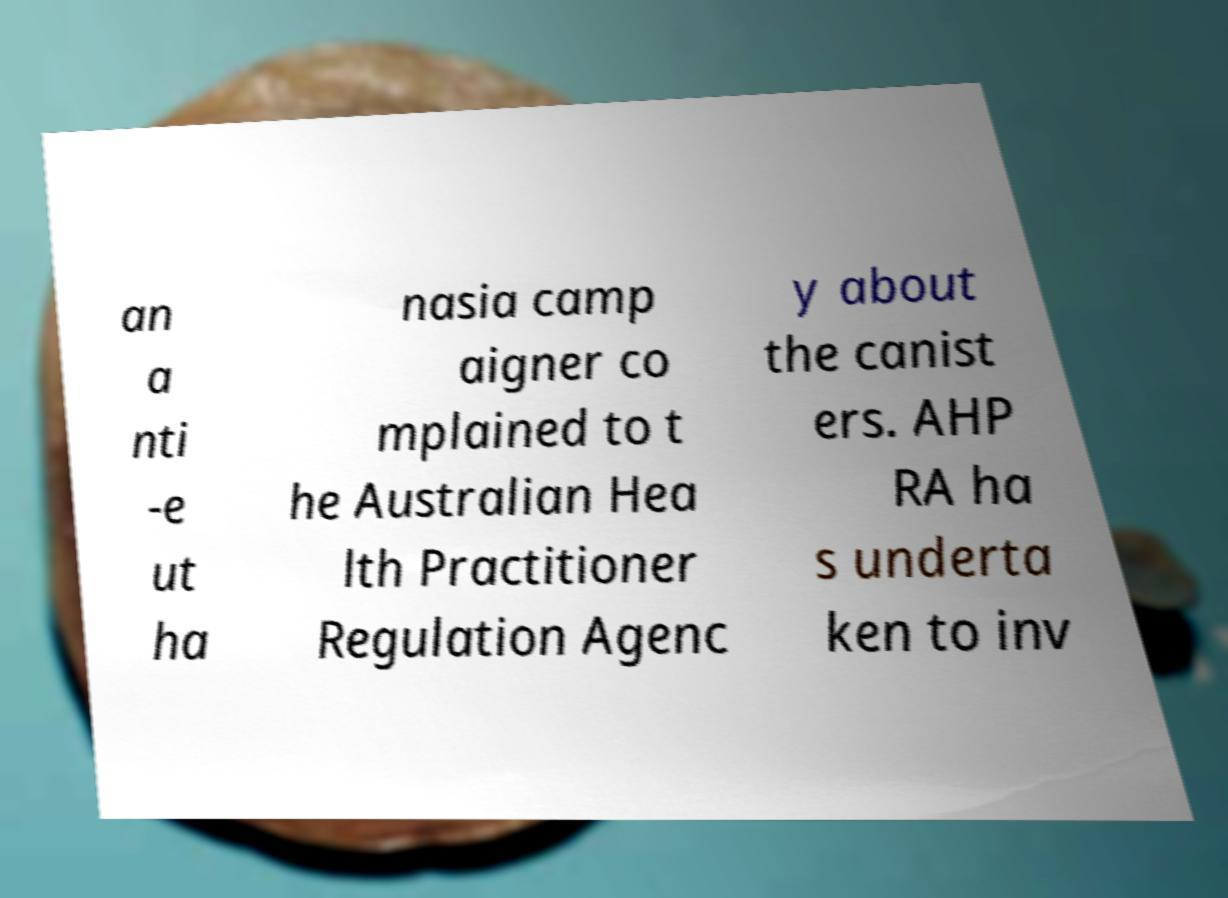Could you assist in decoding the text presented in this image and type it out clearly? an a nti -e ut ha nasia camp aigner co mplained to t he Australian Hea lth Practitioner Regulation Agenc y about the canist ers. AHP RA ha s underta ken to inv 